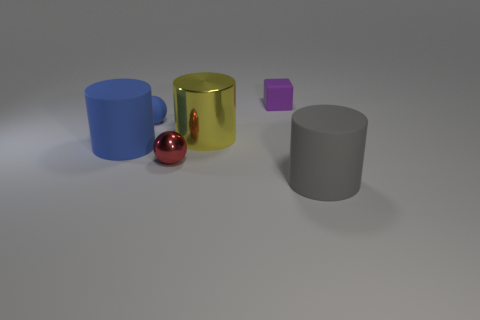What material is the object that is the same color as the tiny rubber ball?
Your response must be concise. Rubber. The red metal thing that is the same shape as the small blue thing is what size?
Give a very brief answer. Small. Is there anything else that is the same size as the gray rubber object?
Keep it short and to the point. Yes. What number of things are tiny spheres in front of the small blue matte sphere or tiny rubber objects behind the small blue rubber object?
Your answer should be compact. 2. Is the yellow metallic object the same size as the blue matte cylinder?
Your answer should be very brief. Yes. Are there more large gray rubber cylinders than tiny balls?
Offer a very short reply. No. What number of other objects are the same color as the metal ball?
Ensure brevity in your answer.  0. How many things are big yellow rubber cylinders or small metal balls?
Provide a short and direct response. 1. Is the shape of the small matte thing to the right of the tiny metal thing the same as  the yellow thing?
Provide a succinct answer. No. What color is the matte object that is in front of the small sphere that is in front of the big blue cylinder?
Give a very brief answer. Gray. 